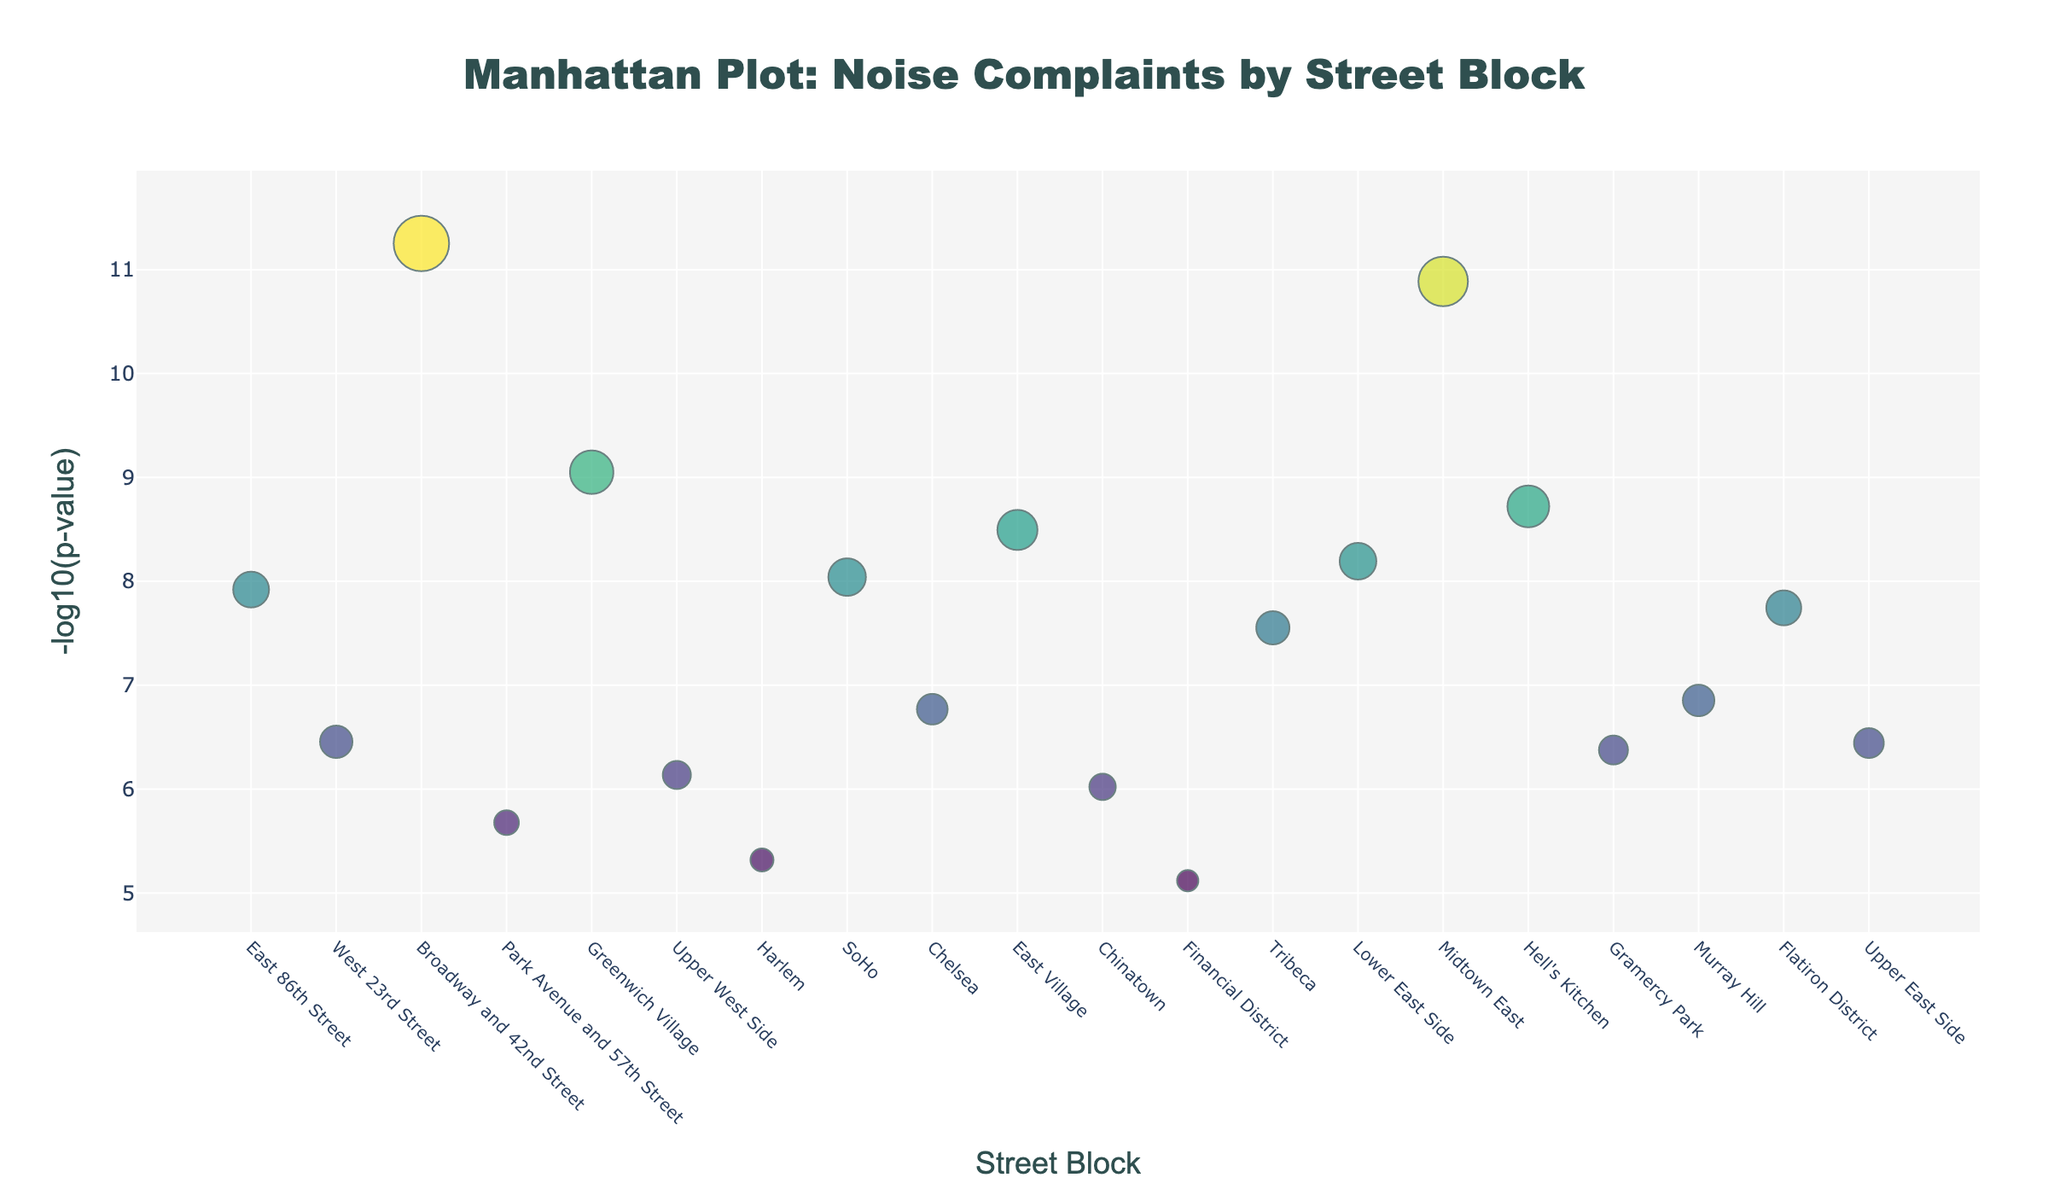How many street blocks are shown in the plot? Count the number of unique street blocks plotted on the x-axis.
Answer: 19 What is the highest -log10(p-value) displayed, and which street block does it correspond to? Identify the marker with the highest position on the y-axis and check its associated street block from the hover text.
Answer: Broadway and 42nd Street, 11.25 Which street block has the highest number of noise complaints? Find the largest marker size, and refer to its associated street block.
Answer: Broadway and 42nd Street Which two street blocks have the closest -log10(p-values)? Look for the markers closest to each other on the y-axis, then check their corresponding street blocks and -log10(p-values).
Answer: Harlem and Financial District, 5.32 What is the difference in -log10(p-value) between East 86th Street and Hell's Kitchen? Identify the -log10(p-values) for both street blocks and subtract the smaller from the larger one.
Answer: 1.44 Which street block in Greenwich Village has a higher -log10(p-value)? The step is simple. Identify Greenwich Village's marker on the plot, noting its position on the y-axis for comparison with other blocks in the visual figure.
Answer: Greenwich Village Which street block in Midtown East compares to Upper East Side in terms of noise complaint counts? Check the hover text for both markers to compare complaint counts for Midtown East and Upper East Side.
Answer: Midtown East: 58, Upper East Side: 35 What does a larger marker size indicate? The size of the marker represents the number of noise complaints; the larger the size, the higher the number of complaints.
Answer: More noise complaints How does the -log10(p-value) for Tribeca compare with that of Chelsea? Compare the y-axis positions of Tribeca's and Chelsea’s markers to determine which has a higher -log10(p-value).
Answer: Tribeca is higher Identify which street block falls within a -log10(p-value) range of 6 to 7? Look for markers whose y-axis positions fall between 6 and 7, and check their hover text to identify the associated street block.
Answer: Lower East Side 